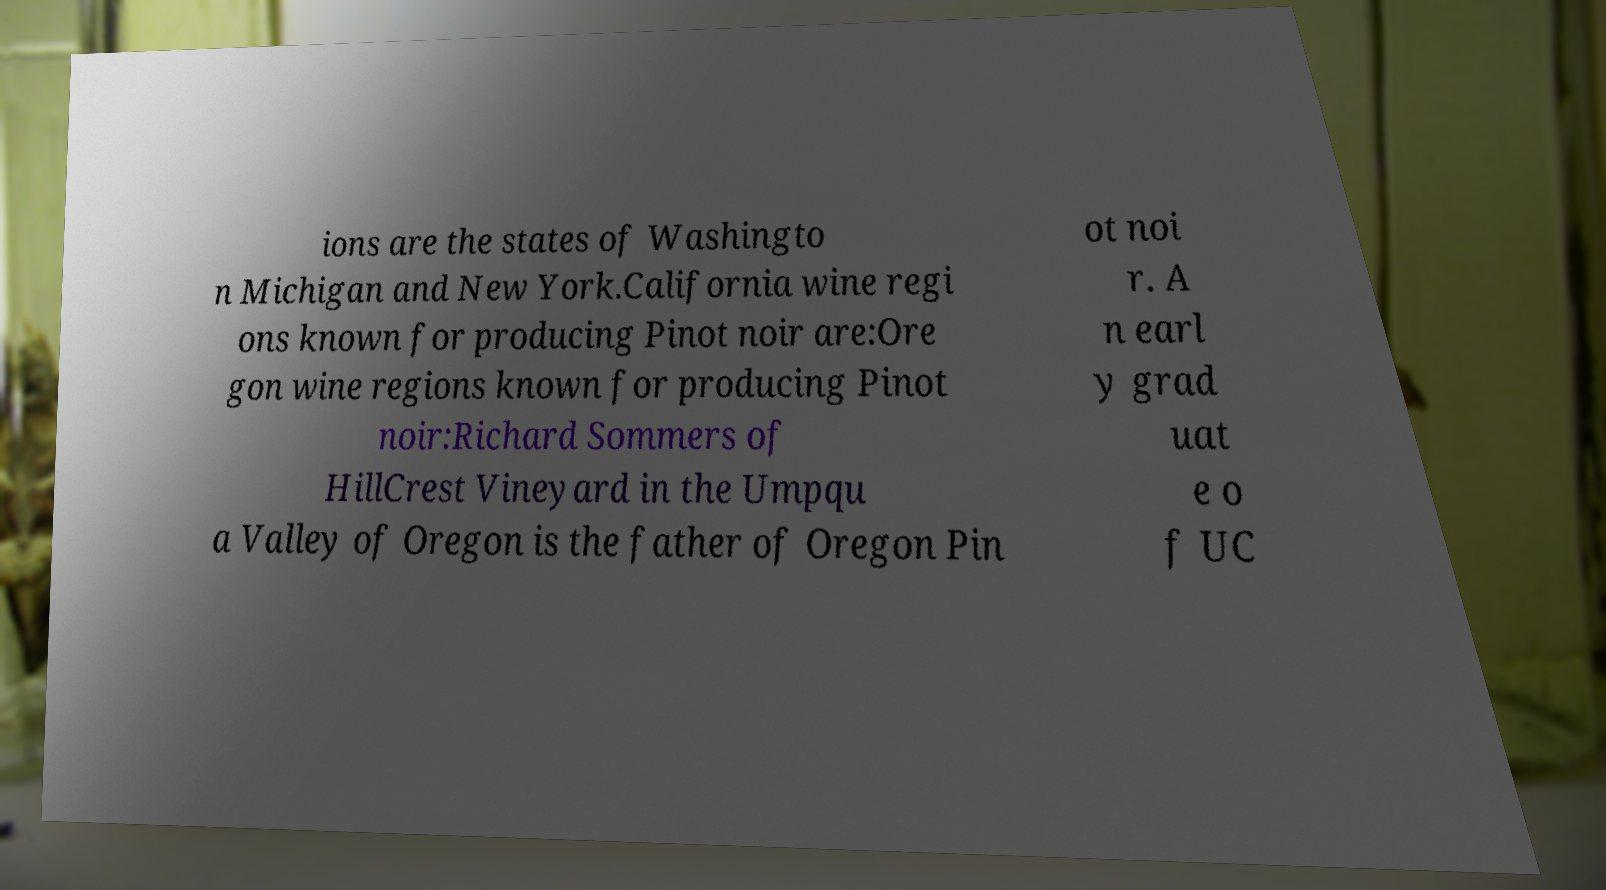I need the written content from this picture converted into text. Can you do that? ions are the states of Washingto n Michigan and New York.California wine regi ons known for producing Pinot noir are:Ore gon wine regions known for producing Pinot noir:Richard Sommers of HillCrest Vineyard in the Umpqu a Valley of Oregon is the father of Oregon Pin ot noi r. A n earl y grad uat e o f UC 